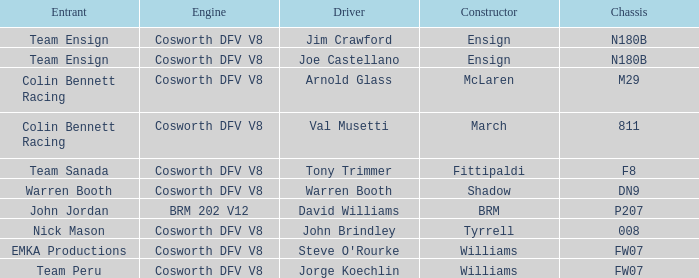What engine is used by Colin Bennett Racing with an 811 chassis? Cosworth DFV V8. 